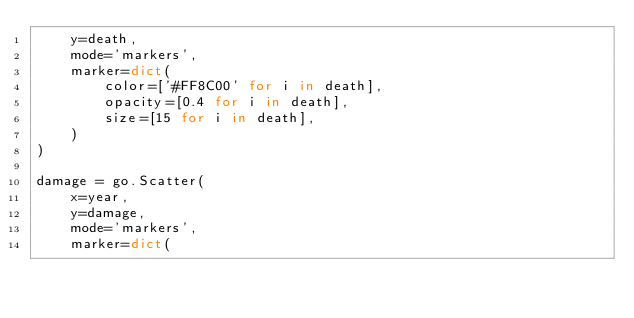<code> <loc_0><loc_0><loc_500><loc_500><_Python_>    y=death,
    mode='markers',
    marker=dict(
        color=['#FF8C00' for i in death],
        opacity=[0.4 for i in death],
        size=[15 for i in death],
    )
)

damage = go.Scatter(
    x=year,
    y=damage,
    mode='markers',
    marker=dict(</code> 